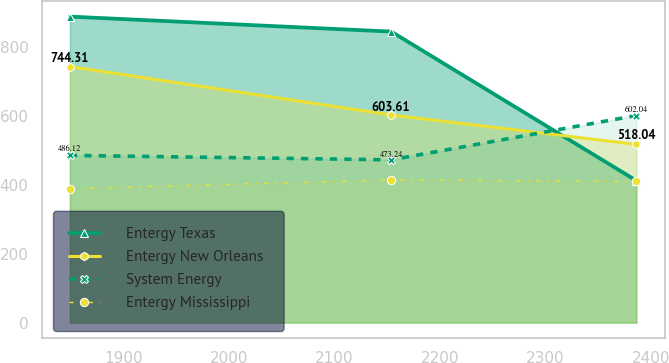<chart> <loc_0><loc_0><loc_500><loc_500><line_chart><ecel><fcel>Entergy Texas<fcel>Entergy New Orleans<fcel>System Energy<fcel>Entergy Mississippi<nl><fcel>1849.12<fcel>889.59<fcel>744.31<fcel>486.12<fcel>389.5<nl><fcel>2153.76<fcel>846.01<fcel>603.61<fcel>473.24<fcel>414.86<nl><fcel>2386.11<fcel>412.79<fcel>518.04<fcel>602.04<fcel>410.31<nl></chart> 